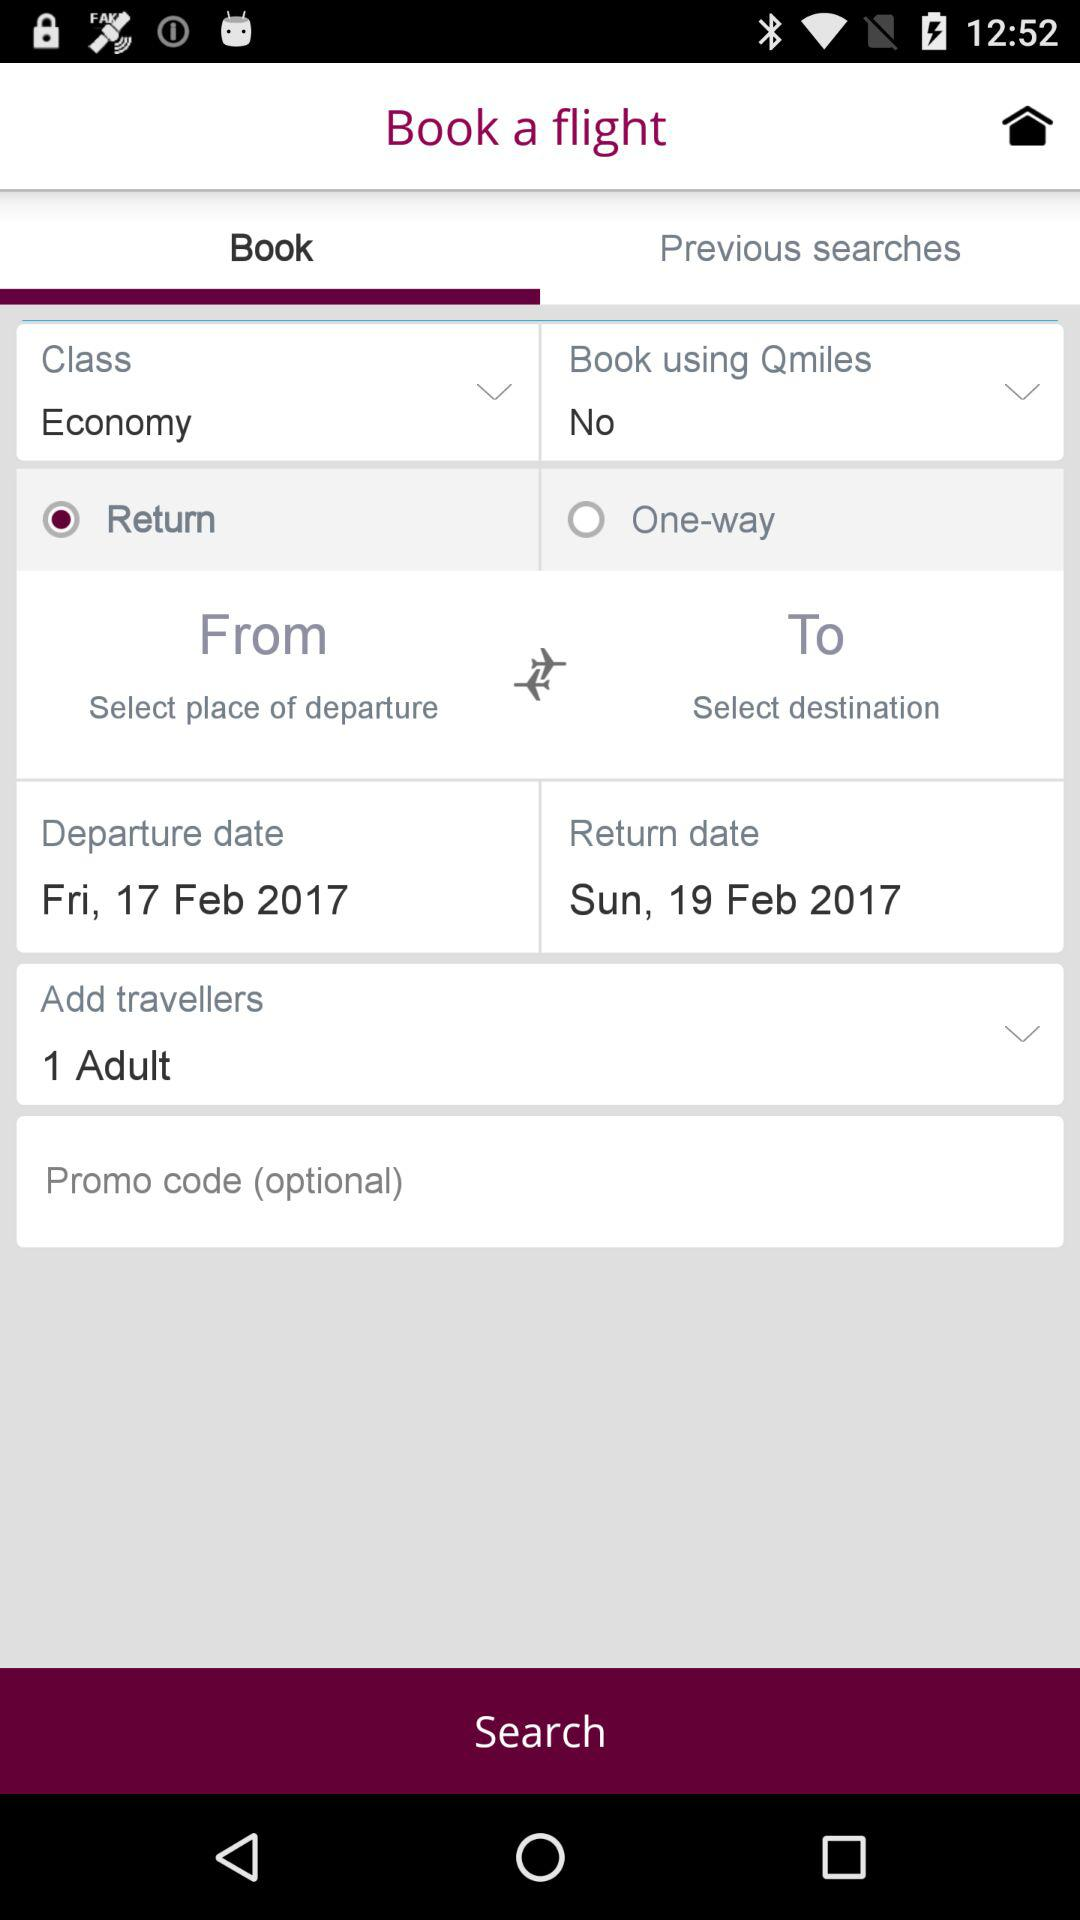Which city was selected as the destination in the most recent previous search?
When the provided information is insufficient, respond with <no answer>. <no answer> 